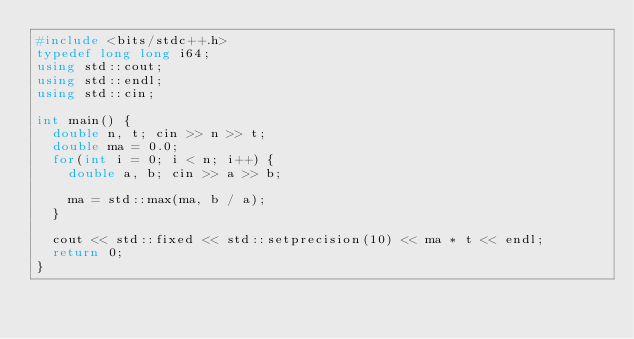<code> <loc_0><loc_0><loc_500><loc_500><_C++_>#include <bits/stdc++.h>
typedef long long i64;
using std::cout;
using std::endl;
using std::cin;

int main() {
	double n, t; cin >> n >> t;
	double ma = 0.0;
	for(int i = 0; i < n; i++) {
		double a, b; cin >> a >> b;
		
		ma = std::max(ma, b / a);
	}
	
	cout << std::fixed << std::setprecision(10) << ma * t << endl;
	return 0;
}

</code> 